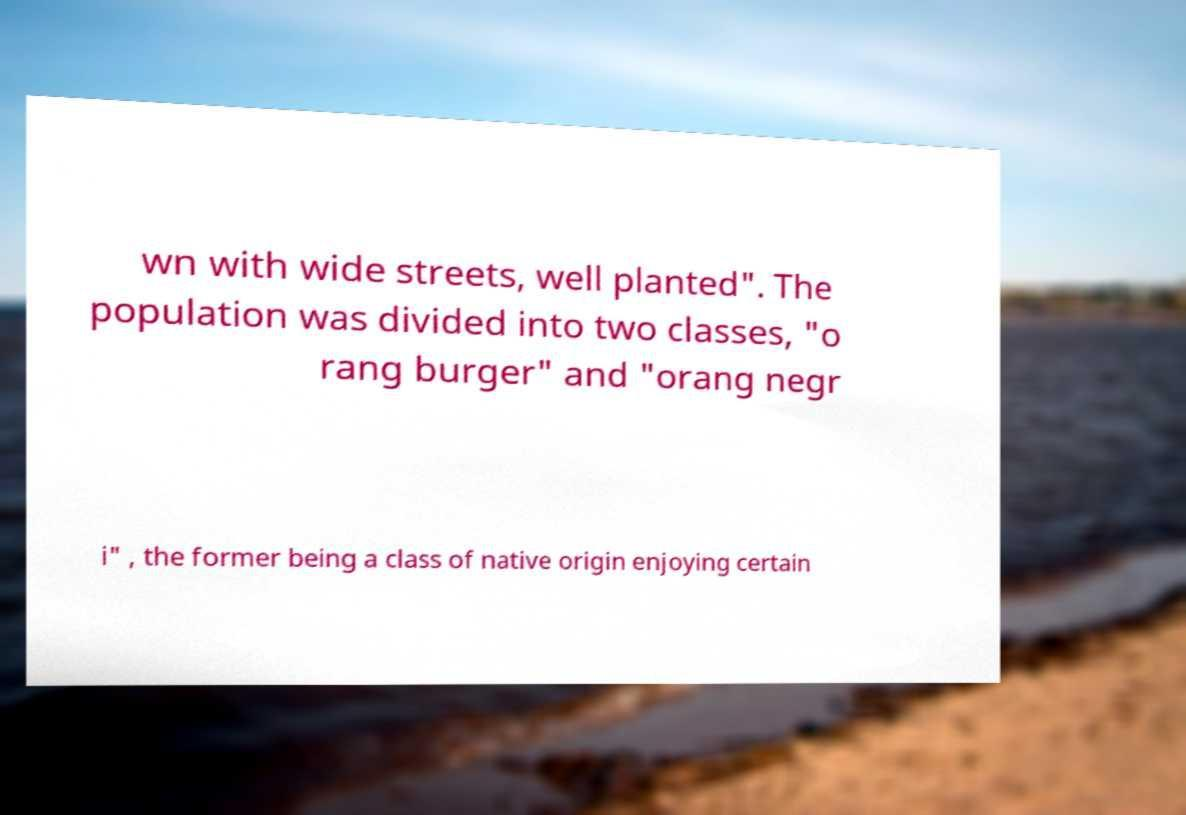Could you extract and type out the text from this image? wn with wide streets, well planted". The population was divided into two classes, "o rang burger" and "orang negr i" , the former being a class of native origin enjoying certain 